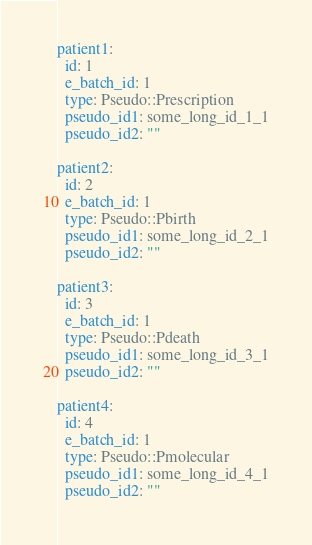Convert code to text. <code><loc_0><loc_0><loc_500><loc_500><_YAML_>patient1:
  id: 1
  e_batch_id: 1
  type: Pseudo::Prescription
  pseudo_id1: some_long_id_1_1
  pseudo_id2: ""

patient2:
  id: 2
  e_batch_id: 1
  type: Pseudo::Pbirth
  pseudo_id1: some_long_id_2_1
  pseudo_id2: ""

patient3:
  id: 3
  e_batch_id: 1
  type: Pseudo::Pdeath
  pseudo_id1: some_long_id_3_1
  pseudo_id2: ""

patient4:
  id: 4
  e_batch_id: 1
  type: Pseudo::Pmolecular
  pseudo_id1: some_long_id_4_1
  pseudo_id2: ""
</code> 